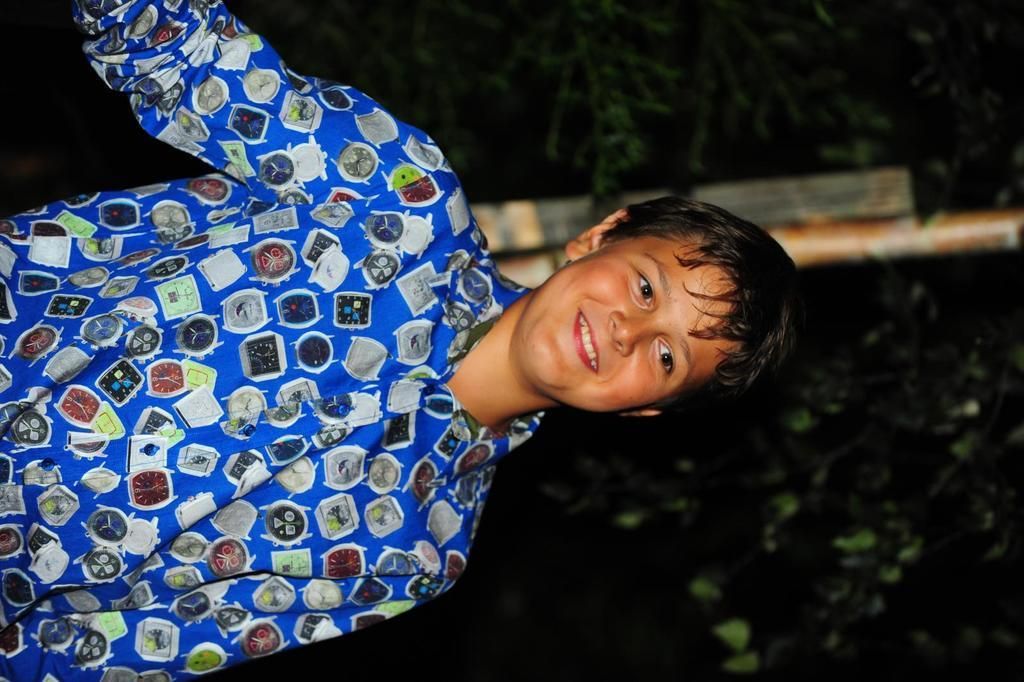Who is the main subject in the picture? There is a boy in the picture. What is the boy doing in the picture? The boy is standing and smiling. What can be seen in the background of the picture? There is a pole and a part of a tree visible in the background of the picture. What type of hole can be seen in the picture? There is no hole present in the picture; it features a boy standing and smiling, with a pole and a part of a tree in the background. 